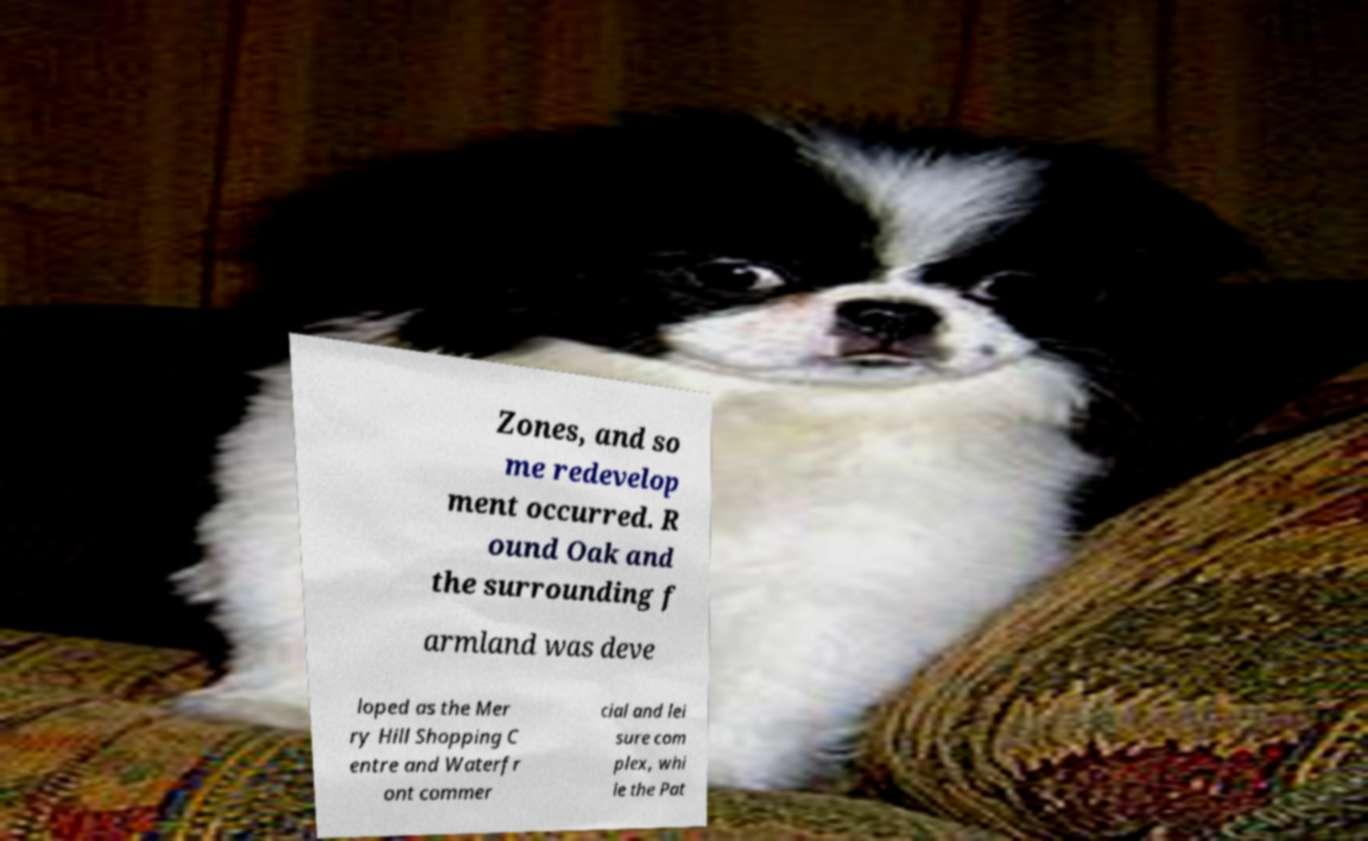Can you read and provide the text displayed in the image?This photo seems to have some interesting text. Can you extract and type it out for me? Zones, and so me redevelop ment occurred. R ound Oak and the surrounding f armland was deve loped as the Mer ry Hill Shopping C entre and Waterfr ont commer cial and lei sure com plex, whi le the Pat 